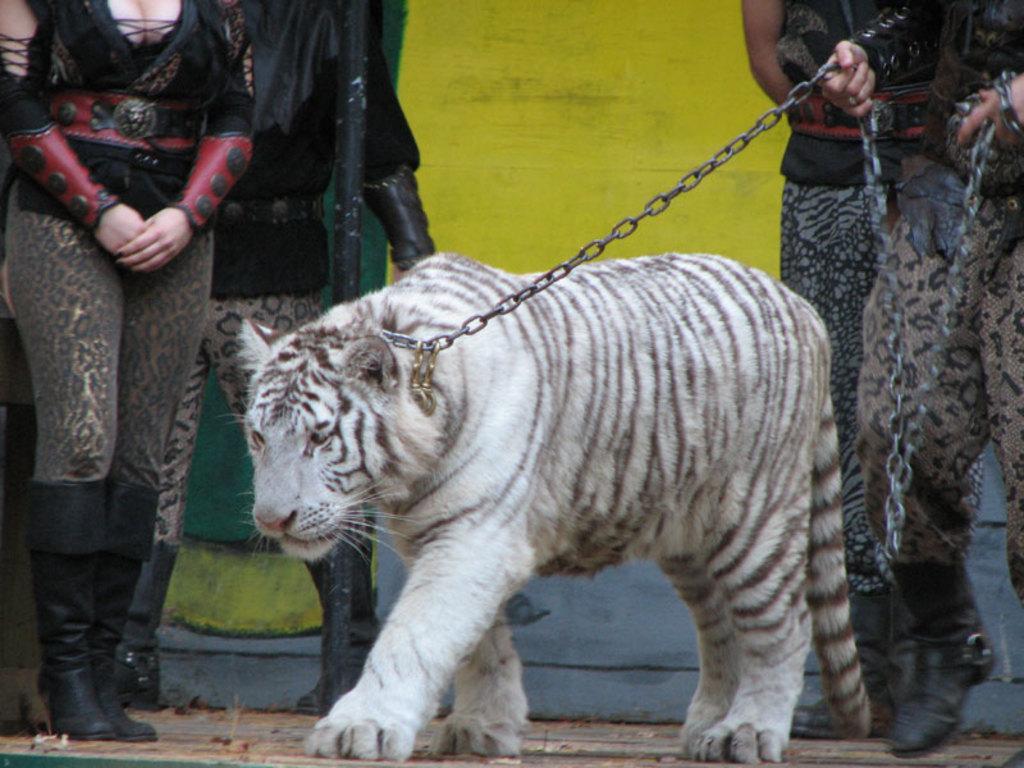Can you describe this image briefly? In the image there is a person holding a white tiger with a chain and behind there are few persons standing in front of the wall. 